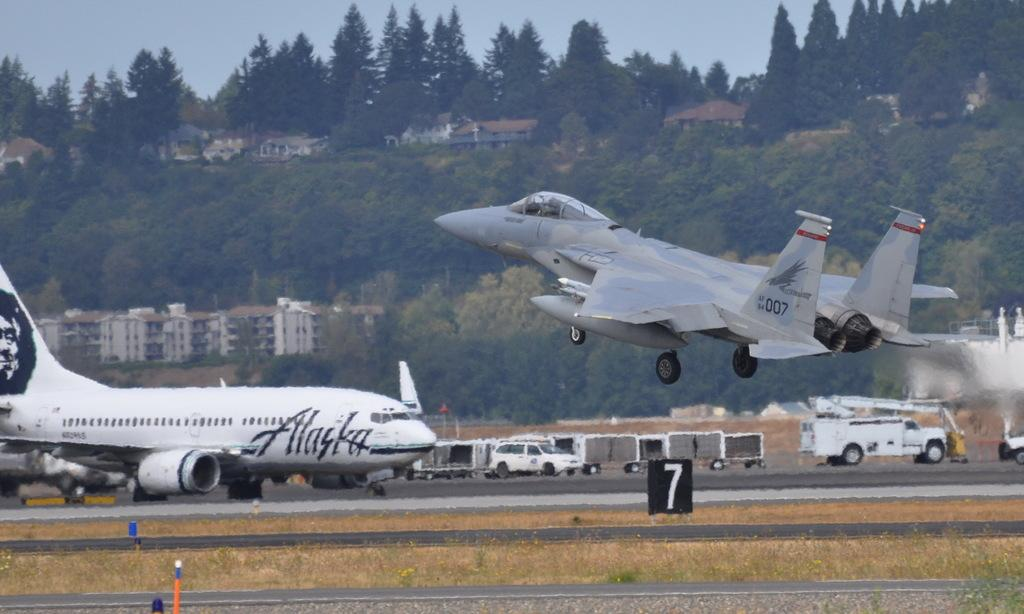<image>
Render a clear and concise summary of the photo. Alaska Airlines planes on the tarmac at an airport. 